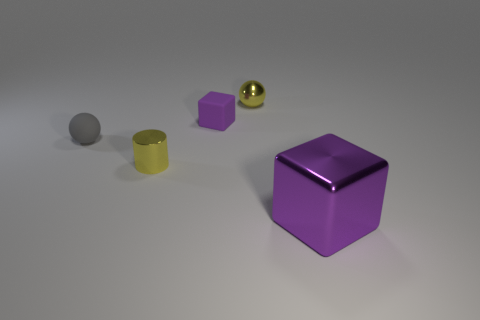Add 5 large purple objects. How many objects exist? 10 Subtract all balls. How many objects are left? 3 Add 2 big metallic blocks. How many big metallic blocks are left? 3 Add 4 big brown matte balls. How many big brown matte balls exist? 4 Subtract 0 green blocks. How many objects are left? 5 Subtract all objects. Subtract all blue matte cylinders. How many objects are left? 0 